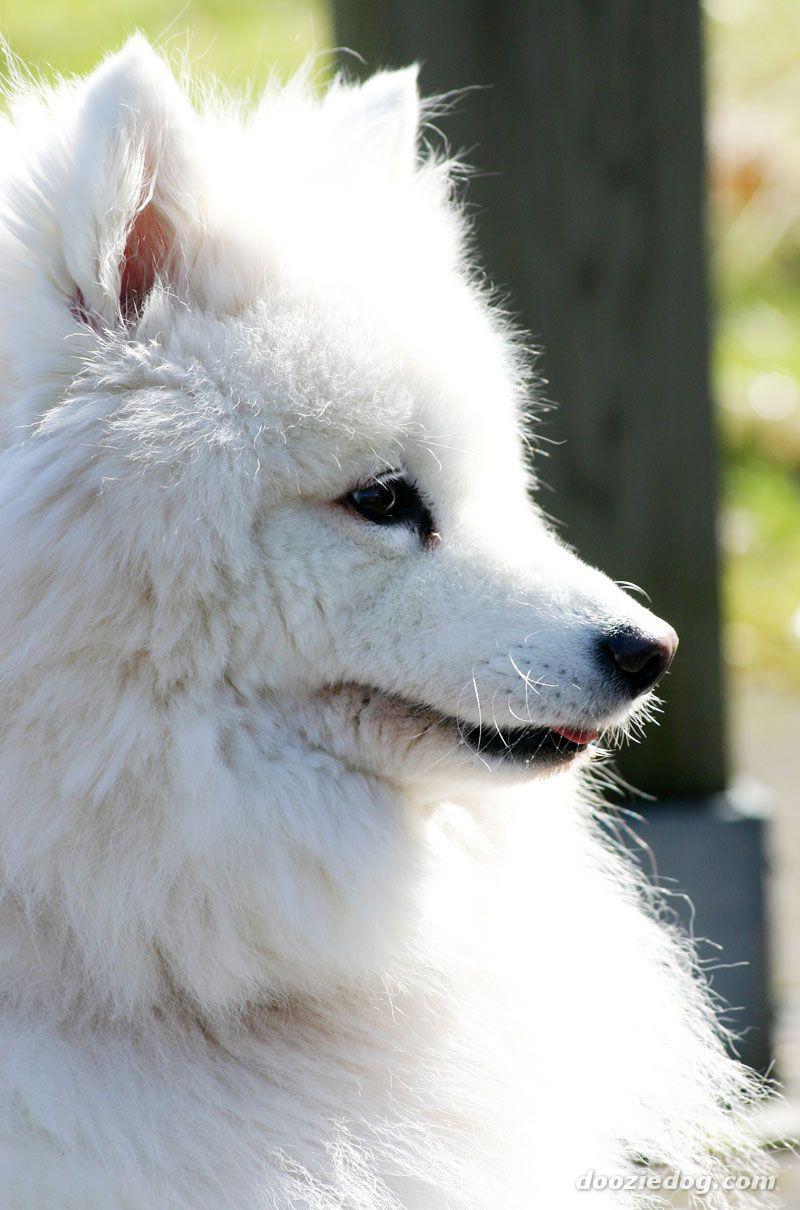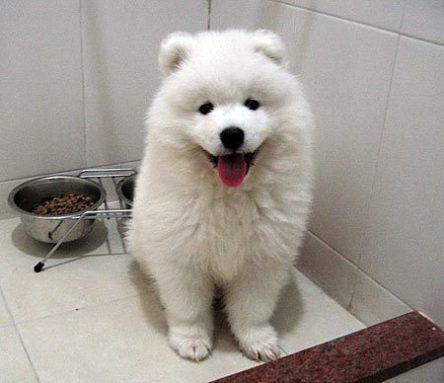The first image is the image on the left, the second image is the image on the right. For the images shown, is this caption "At least one of the images shows a single white dog." true? Answer yes or no. Yes. 